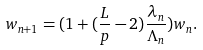<formula> <loc_0><loc_0><loc_500><loc_500>w _ { n + 1 } = ( 1 + ( \frac { L } { p } - 2 ) \frac { \lambda _ { n } } { \Lambda _ { n } } ) w _ { n } .</formula> 